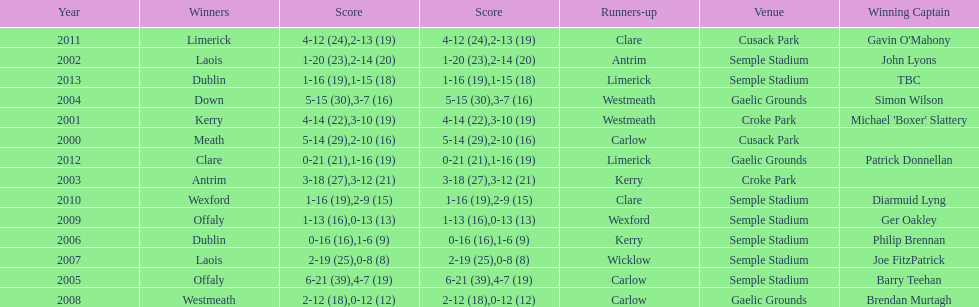Write the full table. {'header': ['Year', 'Winners', 'Score', 'Score', 'Runners-up', 'Venue', 'Winning Captain'], 'rows': [['2011', 'Limerick', '4-12 (24)', '2-13 (19)', 'Clare', 'Cusack Park', "Gavin O'Mahony"], ['2002', 'Laois', '1-20 (23)', '2-14 (20)', 'Antrim', 'Semple Stadium', 'John Lyons'], ['2013', 'Dublin', '1-16 (19)', '1-15 (18)', 'Limerick', 'Semple Stadium', 'TBC'], ['2004', 'Down', '5-15 (30)', '3-7 (16)', 'Westmeath', 'Gaelic Grounds', 'Simon Wilson'], ['2001', 'Kerry', '4-14 (22)', '3-10 (19)', 'Westmeath', 'Croke Park', "Michael 'Boxer' Slattery"], ['2000', 'Meath', '5-14 (29)', '2-10 (16)', 'Carlow', 'Cusack Park', ''], ['2012', 'Clare', '0-21 (21)', '1-16 (19)', 'Limerick', 'Gaelic Grounds', 'Patrick Donnellan'], ['2003', 'Antrim', '3-18 (27)', '3-12 (21)', 'Kerry', 'Croke Park', ''], ['2010', 'Wexford', '1-16 (19)', '2-9 (15)', 'Clare', 'Semple Stadium', 'Diarmuid Lyng'], ['2009', 'Offaly', '1-13 (16)', '0-13 (13)', 'Wexford', 'Semple Stadium', 'Ger Oakley'], ['2006', 'Dublin', '0-16 (16)', '1-6 (9)', 'Kerry', 'Semple Stadium', 'Philip Brennan'], ['2007', 'Laois', '2-19 (25)', '0-8 (8)', 'Wicklow', 'Semple Stadium', 'Joe FitzPatrick'], ['2005', 'Offaly', '6-21 (39)', '4-7 (19)', 'Carlow', 'Semple Stadium', 'Barry Teehan'], ['2008', 'Westmeath', '2-12 (18)', '0-12 (12)', 'Carlow', 'Gaelic Grounds', 'Brendan Murtagh']]} Who was the first winner in 2013? Dublin. 